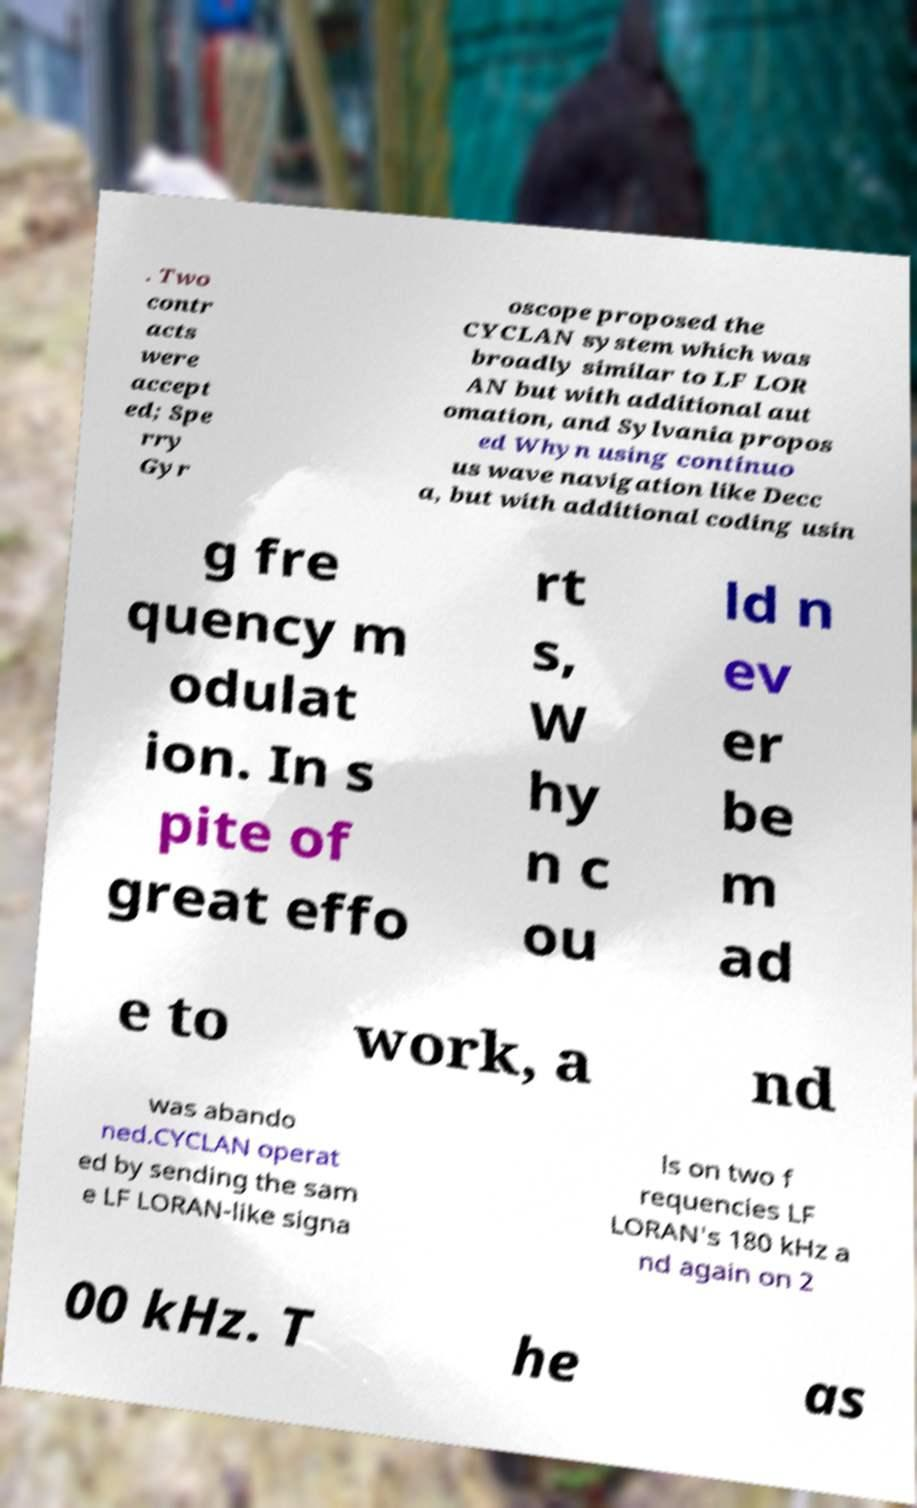For documentation purposes, I need the text within this image transcribed. Could you provide that? . Two contr acts were accept ed; Spe rry Gyr oscope proposed the CYCLAN system which was broadly similar to LF LOR AN but with additional aut omation, and Sylvania propos ed Whyn using continuo us wave navigation like Decc a, but with additional coding usin g fre quency m odulat ion. In s pite of great effo rt s, W hy n c ou ld n ev er be m ad e to work, a nd was abando ned.CYCLAN operat ed by sending the sam e LF LORAN-like signa ls on two f requencies LF LORAN's 180 kHz a nd again on 2 00 kHz. T he as 